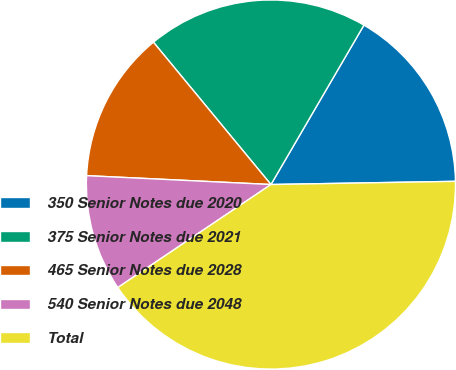<chart> <loc_0><loc_0><loc_500><loc_500><pie_chart><fcel>350 Senior Notes due 2020<fcel>375 Senior Notes due 2021<fcel>465 Senior Notes due 2028<fcel>540 Senior Notes due 2048<fcel>Total<nl><fcel>16.32%<fcel>19.39%<fcel>13.25%<fcel>10.19%<fcel>40.85%<nl></chart> 